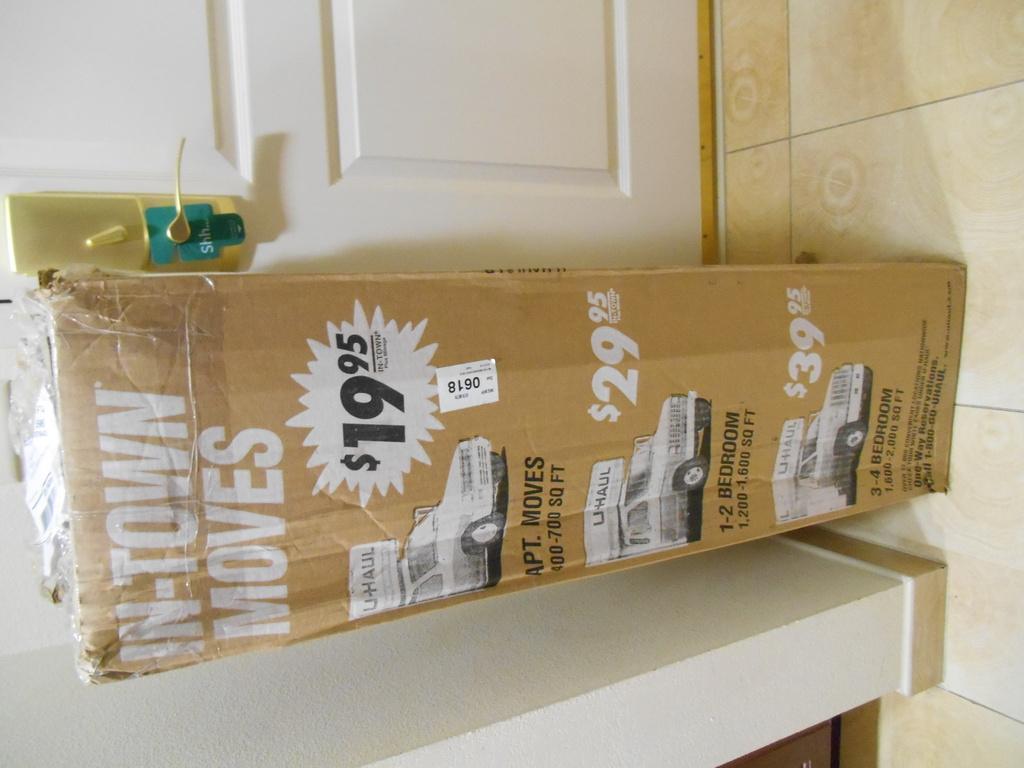How much do apartment moves cost?
Make the answer very short. $19.95. What is the first word on the left side of the box say?
Provide a succinct answer. In-town. 